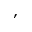<formula> <loc_0><loc_0><loc_500><loc_500>,</formula> 